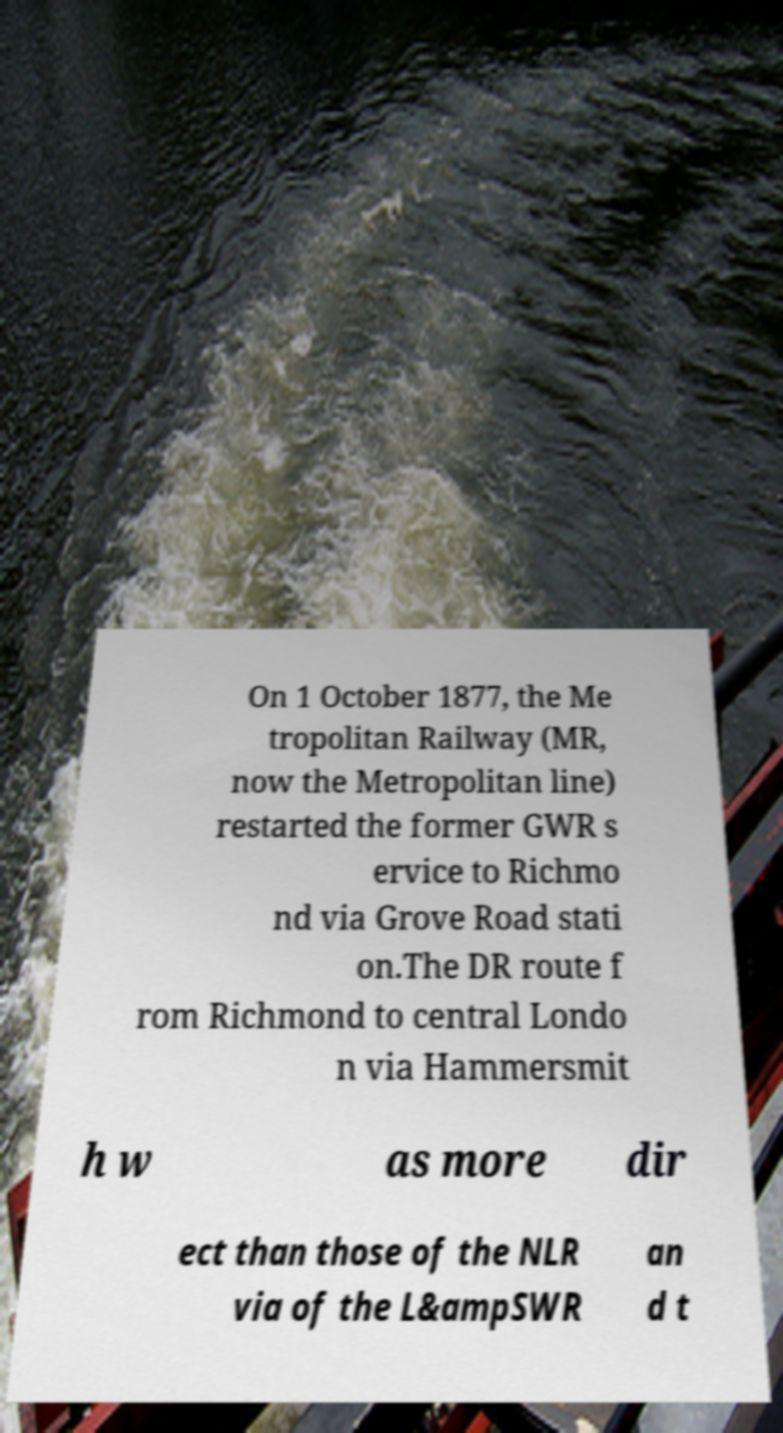Can you read and provide the text displayed in the image?This photo seems to have some interesting text. Can you extract and type it out for me? On 1 October 1877, the Me tropolitan Railway (MR, now the Metropolitan line) restarted the former GWR s ervice to Richmo nd via Grove Road stati on.The DR route f rom Richmond to central Londo n via Hammersmit h w as more dir ect than those of the NLR via of the L&ampSWR an d t 